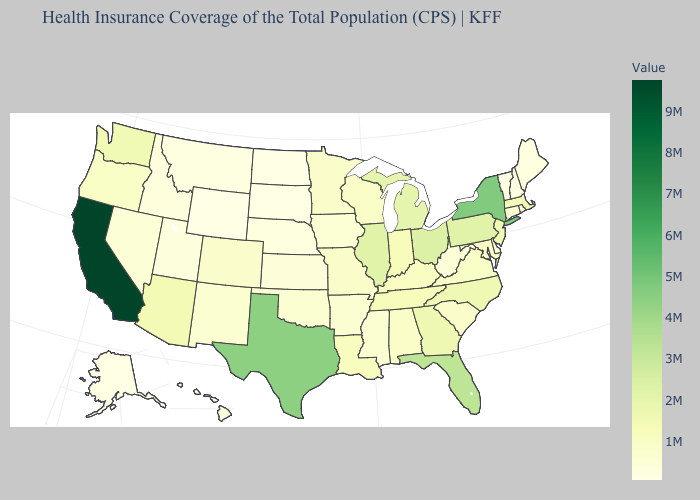Does Wyoming have the lowest value in the USA?
Quick response, please. Yes. Among the states that border Ohio , does Indiana have the highest value?
Write a very short answer. No. Does New Mexico have the lowest value in the USA?
Give a very brief answer. No. Which states have the lowest value in the West?
Concise answer only. Wyoming. Does the map have missing data?
Write a very short answer. No. Among the states that border New Jersey , which have the lowest value?
Be succinct. Delaware. 